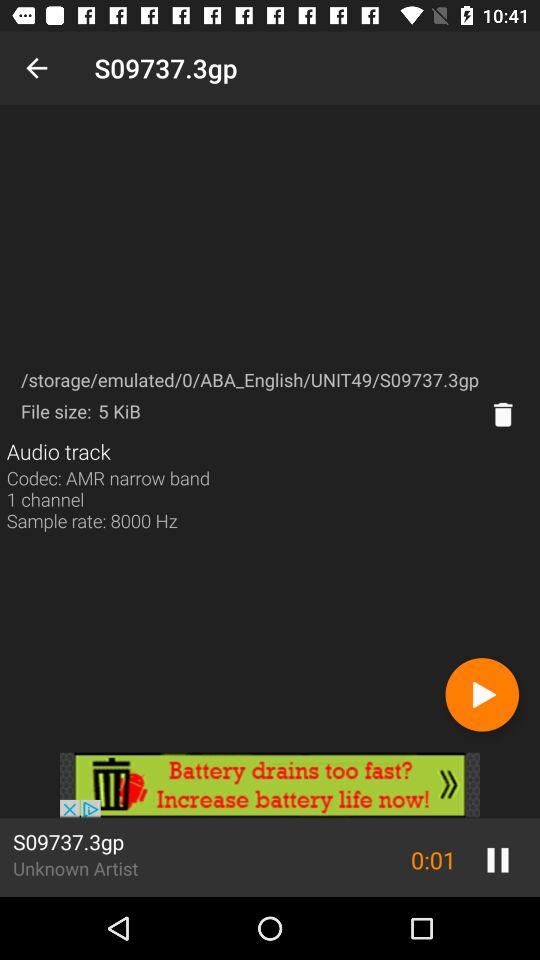What is the file size? The file size is 5 KiB. 